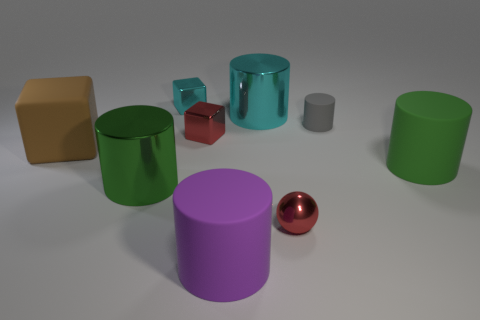Subtract all large cyan cylinders. How many cylinders are left? 4 Subtract all purple cylinders. How many cylinders are left? 4 Add 9 matte cubes. How many matte cubes exist? 10 Subtract 1 green cylinders. How many objects are left? 8 Subtract all cylinders. How many objects are left? 4 Subtract 2 cubes. How many cubes are left? 1 Subtract all blue cubes. Subtract all cyan balls. How many cubes are left? 3 Subtract all brown cylinders. How many brown blocks are left? 1 Subtract all small purple matte objects. Subtract all big objects. How many objects are left? 4 Add 4 red metallic blocks. How many red metallic blocks are left? 5 